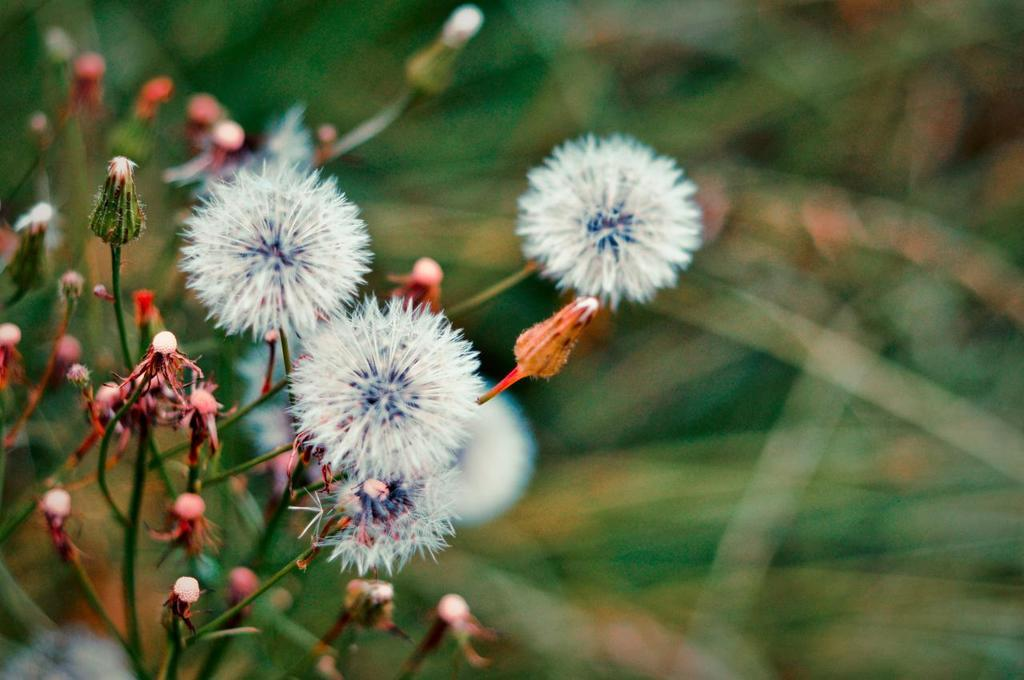What type of plants are on the left side of the image? There are plants with flowers on the left side of the image. What color are some of the flowers? Some of the flowers are white. Can you describe the background of the image? The background of the image is blurred. How many sisters can be seen in the image? There are no sisters present in the image; it features plants with flowers and a blurred background. 